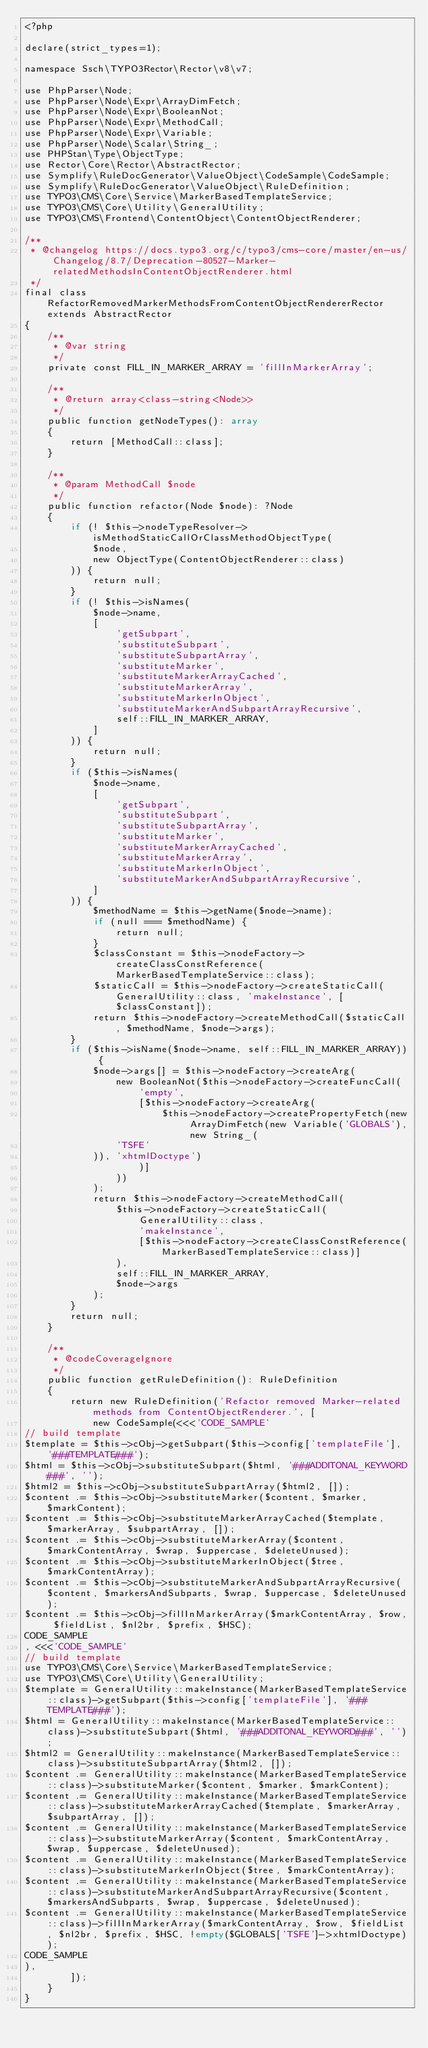<code> <loc_0><loc_0><loc_500><loc_500><_PHP_><?php

declare(strict_types=1);

namespace Ssch\TYPO3Rector\Rector\v8\v7;

use PhpParser\Node;
use PhpParser\Node\Expr\ArrayDimFetch;
use PhpParser\Node\Expr\BooleanNot;
use PhpParser\Node\Expr\MethodCall;
use PhpParser\Node\Expr\Variable;
use PhpParser\Node\Scalar\String_;
use PHPStan\Type\ObjectType;
use Rector\Core\Rector\AbstractRector;
use Symplify\RuleDocGenerator\ValueObject\CodeSample\CodeSample;
use Symplify\RuleDocGenerator\ValueObject\RuleDefinition;
use TYPO3\CMS\Core\Service\MarkerBasedTemplateService;
use TYPO3\CMS\Core\Utility\GeneralUtility;
use TYPO3\CMS\Frontend\ContentObject\ContentObjectRenderer;

/**
 * @changelog https://docs.typo3.org/c/typo3/cms-core/master/en-us/Changelog/8.7/Deprecation-80527-Marker-relatedMethodsInContentObjectRenderer.html
 */
final class RefactorRemovedMarkerMethodsFromContentObjectRendererRector extends AbstractRector
{
    /**
     * @var string
     */
    private const FILL_IN_MARKER_ARRAY = 'fillInMarkerArray';

    /**
     * @return array<class-string<Node>>
     */
    public function getNodeTypes(): array
    {
        return [MethodCall::class];
    }

    /**
     * @param MethodCall $node
     */
    public function refactor(Node $node): ?Node
    {
        if (! $this->nodeTypeResolver->isMethodStaticCallOrClassMethodObjectType(
            $node,
            new ObjectType(ContentObjectRenderer::class)
        )) {
            return null;
        }
        if (! $this->isNames(
            $node->name,
            [
                'getSubpart',
                'substituteSubpart',
                'substituteSubpartArray',
                'substituteMarker',
                'substituteMarkerArrayCached',
                'substituteMarkerArray',
                'substituteMarkerInObject',
                'substituteMarkerAndSubpartArrayRecursive',
                self::FILL_IN_MARKER_ARRAY,
            ]
        )) {
            return null;
        }
        if ($this->isNames(
            $node->name,
            [
                'getSubpart',
                'substituteSubpart',
                'substituteSubpartArray',
                'substituteMarker',
                'substituteMarkerArrayCached',
                'substituteMarkerArray',
                'substituteMarkerInObject',
                'substituteMarkerAndSubpartArrayRecursive',
            ]
        )) {
            $methodName = $this->getName($node->name);
            if (null === $methodName) {
                return null;
            }
            $classConstant = $this->nodeFactory->createClassConstReference(MarkerBasedTemplateService::class);
            $staticCall = $this->nodeFactory->createStaticCall(GeneralUtility::class, 'makeInstance', [$classConstant]);
            return $this->nodeFactory->createMethodCall($staticCall, $methodName, $node->args);
        }
        if ($this->isName($node->name, self::FILL_IN_MARKER_ARRAY)) {
            $node->args[] = $this->nodeFactory->createArg(
                new BooleanNot($this->nodeFactory->createFuncCall(
                    'empty',
                    [$this->nodeFactory->createArg(
                        $this->nodeFactory->createPropertyFetch(new ArrayDimFetch(new Variable('GLOBALS'), new String_(
                'TSFE'
            )), 'xhtmlDoctype')
                    )]
                ))
            );
            return $this->nodeFactory->createMethodCall(
                $this->nodeFactory->createStaticCall(
                    GeneralUtility::class,
                    'makeInstance',
                    [$this->nodeFactory->createClassConstReference(MarkerBasedTemplateService::class)]
                ),
                self::FILL_IN_MARKER_ARRAY,
                $node->args
            );
        }
        return null;
    }

    /**
     * @codeCoverageIgnore
     */
    public function getRuleDefinition(): RuleDefinition
    {
        return new RuleDefinition('Refactor removed Marker-related methods from ContentObjectRenderer.', [
            new CodeSample(<<<'CODE_SAMPLE'
// build template
$template = $this->cObj->getSubpart($this->config['templateFile'], '###TEMPLATE###');
$html = $this->cObj->substituteSubpart($html, '###ADDITONAL_KEYWORD###', '');
$html2 = $this->cObj->substituteSubpartArray($html2, []);
$content .= $this->cObj->substituteMarker($content, $marker, $markContent);
$content .= $this->cObj->substituteMarkerArrayCached($template, $markerArray, $subpartArray, []);
$content .= $this->cObj->substituteMarkerArray($content, $markContentArray, $wrap, $uppercase, $deleteUnused);
$content .= $this->cObj->substituteMarkerInObject($tree, $markContentArray);
$content .= $this->cObj->substituteMarkerAndSubpartArrayRecursive($content, $markersAndSubparts, $wrap, $uppercase, $deleteUnused);
$content .= $this->cObj->fillInMarkerArray($markContentArray, $row, $fieldList, $nl2br, $prefix, $HSC);
CODE_SAMPLE
, <<<'CODE_SAMPLE'
// build template
use TYPO3\CMS\Core\Service\MarkerBasedTemplateService;
use TYPO3\CMS\Core\Utility\GeneralUtility;
$template = GeneralUtility::makeInstance(MarkerBasedTemplateService::class)->getSubpart($this->config['templateFile'], '###TEMPLATE###');
$html = GeneralUtility::makeInstance(MarkerBasedTemplateService::class)->substituteSubpart($html, '###ADDITONAL_KEYWORD###', '');
$html2 = GeneralUtility::makeInstance(MarkerBasedTemplateService::class)->substituteSubpartArray($html2, []);
$content .= GeneralUtility::makeInstance(MarkerBasedTemplateService::class)->substituteMarker($content, $marker, $markContent);
$content .= GeneralUtility::makeInstance(MarkerBasedTemplateService::class)->substituteMarkerArrayCached($template, $markerArray, $subpartArray, []);
$content .= GeneralUtility::makeInstance(MarkerBasedTemplateService::class)->substituteMarkerArray($content, $markContentArray, $wrap, $uppercase, $deleteUnused);
$content .= GeneralUtility::makeInstance(MarkerBasedTemplateService::class)->substituteMarkerInObject($tree, $markContentArray);
$content .= GeneralUtility::makeInstance(MarkerBasedTemplateService::class)->substituteMarkerAndSubpartArrayRecursive($content, $markersAndSubparts, $wrap, $uppercase, $deleteUnused);
$content .= GeneralUtility::makeInstance(MarkerBasedTemplateService::class)->fillInMarkerArray($markContentArray, $row, $fieldList, $nl2br, $prefix, $HSC, !empty($GLOBALS['TSFE']->xhtmlDoctype));
CODE_SAMPLE
),
        ]);
    }
}
</code> 